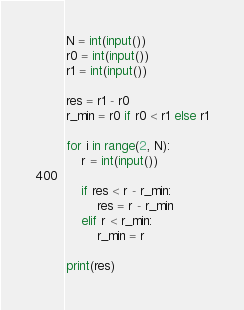Convert code to text. <code><loc_0><loc_0><loc_500><loc_500><_Python_>N = int(input())
r0 = int(input())
r1 = int(input())

res = r1 - r0
r_min = r0 if r0 < r1 else r1

for i in range(2, N):
    r = int(input())

    if res < r - r_min:
        res = r - r_min
    elif r < r_min:
        r_min = r

print(res)

</code> 